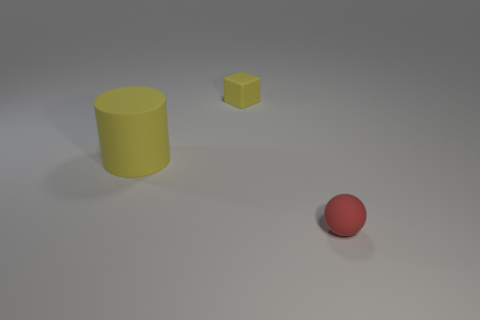Add 3 yellow matte blocks. How many objects exist? 6 Subtract all blocks. How many objects are left? 2 Subtract all matte cylinders. Subtract all tiny yellow rubber objects. How many objects are left? 1 Add 3 big rubber things. How many big rubber things are left? 4 Add 3 tiny yellow matte objects. How many tiny yellow matte objects exist? 4 Subtract 0 blue balls. How many objects are left? 3 